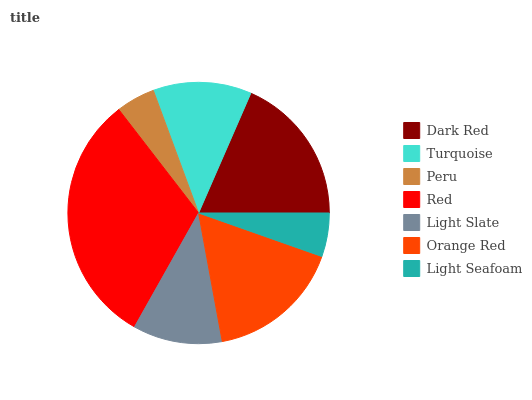Is Peru the minimum?
Answer yes or no. Yes. Is Red the maximum?
Answer yes or no. Yes. Is Turquoise the minimum?
Answer yes or no. No. Is Turquoise the maximum?
Answer yes or no. No. Is Dark Red greater than Turquoise?
Answer yes or no. Yes. Is Turquoise less than Dark Red?
Answer yes or no. Yes. Is Turquoise greater than Dark Red?
Answer yes or no. No. Is Dark Red less than Turquoise?
Answer yes or no. No. Is Turquoise the high median?
Answer yes or no. Yes. Is Turquoise the low median?
Answer yes or no. Yes. Is Light Slate the high median?
Answer yes or no. No. Is Dark Red the low median?
Answer yes or no. No. 